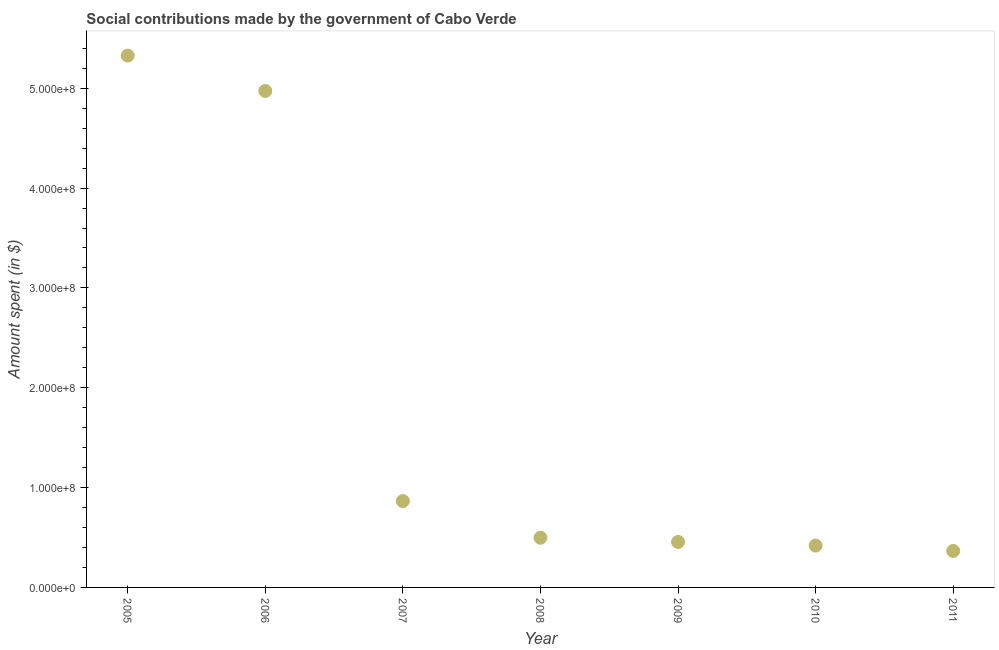What is the amount spent in making social contributions in 2006?
Provide a succinct answer. 4.97e+08. Across all years, what is the maximum amount spent in making social contributions?
Offer a terse response. 5.33e+08. Across all years, what is the minimum amount spent in making social contributions?
Your response must be concise. 3.65e+07. In which year was the amount spent in making social contributions maximum?
Keep it short and to the point. 2005. In which year was the amount spent in making social contributions minimum?
Your answer should be compact. 2011. What is the sum of the amount spent in making social contributions?
Give a very brief answer. 1.29e+09. What is the difference between the amount spent in making social contributions in 2005 and 2008?
Offer a terse response. 4.83e+08. What is the average amount spent in making social contributions per year?
Your answer should be compact. 1.84e+08. What is the median amount spent in making social contributions?
Your answer should be compact. 4.98e+07. Do a majority of the years between 2011 and 2008 (inclusive) have amount spent in making social contributions greater than 440000000 $?
Provide a succinct answer. Yes. What is the ratio of the amount spent in making social contributions in 2007 to that in 2010?
Give a very brief answer. 2.06. Is the amount spent in making social contributions in 2007 less than that in 2011?
Your response must be concise. No. Is the difference between the amount spent in making social contributions in 2010 and 2011 greater than the difference between any two years?
Ensure brevity in your answer.  No. What is the difference between the highest and the second highest amount spent in making social contributions?
Keep it short and to the point. 3.54e+07. What is the difference between the highest and the lowest amount spent in making social contributions?
Your answer should be compact. 4.96e+08. In how many years, is the amount spent in making social contributions greater than the average amount spent in making social contributions taken over all years?
Offer a very short reply. 2. How many dotlines are there?
Your response must be concise. 1. How many years are there in the graph?
Provide a succinct answer. 7. Are the values on the major ticks of Y-axis written in scientific E-notation?
Offer a very short reply. Yes. Does the graph contain any zero values?
Offer a terse response. No. Does the graph contain grids?
Your answer should be very brief. No. What is the title of the graph?
Ensure brevity in your answer.  Social contributions made by the government of Cabo Verde. What is the label or title of the Y-axis?
Provide a succinct answer. Amount spent (in $). What is the Amount spent (in $) in 2005?
Give a very brief answer. 5.33e+08. What is the Amount spent (in $) in 2006?
Provide a succinct answer. 4.97e+08. What is the Amount spent (in $) in 2007?
Keep it short and to the point. 8.65e+07. What is the Amount spent (in $) in 2008?
Your answer should be very brief. 4.98e+07. What is the Amount spent (in $) in 2009?
Keep it short and to the point. 4.56e+07. What is the Amount spent (in $) in 2010?
Provide a succinct answer. 4.19e+07. What is the Amount spent (in $) in 2011?
Ensure brevity in your answer.  3.65e+07. What is the difference between the Amount spent (in $) in 2005 and 2006?
Your answer should be very brief. 3.54e+07. What is the difference between the Amount spent (in $) in 2005 and 2007?
Keep it short and to the point. 4.46e+08. What is the difference between the Amount spent (in $) in 2005 and 2008?
Offer a very short reply. 4.83e+08. What is the difference between the Amount spent (in $) in 2005 and 2009?
Your answer should be very brief. 4.87e+08. What is the difference between the Amount spent (in $) in 2005 and 2010?
Your answer should be very brief. 4.91e+08. What is the difference between the Amount spent (in $) in 2005 and 2011?
Your answer should be very brief. 4.96e+08. What is the difference between the Amount spent (in $) in 2006 and 2007?
Keep it short and to the point. 4.11e+08. What is the difference between the Amount spent (in $) in 2006 and 2008?
Your answer should be very brief. 4.48e+08. What is the difference between the Amount spent (in $) in 2006 and 2009?
Make the answer very short. 4.52e+08. What is the difference between the Amount spent (in $) in 2006 and 2010?
Your answer should be very brief. 4.55e+08. What is the difference between the Amount spent (in $) in 2006 and 2011?
Ensure brevity in your answer.  4.61e+08. What is the difference between the Amount spent (in $) in 2007 and 2008?
Provide a succinct answer. 3.67e+07. What is the difference between the Amount spent (in $) in 2007 and 2009?
Ensure brevity in your answer.  4.10e+07. What is the difference between the Amount spent (in $) in 2007 and 2010?
Your answer should be compact. 4.46e+07. What is the difference between the Amount spent (in $) in 2007 and 2011?
Ensure brevity in your answer.  5.00e+07. What is the difference between the Amount spent (in $) in 2008 and 2009?
Give a very brief answer. 4.24e+06. What is the difference between the Amount spent (in $) in 2008 and 2010?
Offer a very short reply. 7.89e+06. What is the difference between the Amount spent (in $) in 2008 and 2011?
Your response must be concise. 1.33e+07. What is the difference between the Amount spent (in $) in 2009 and 2010?
Keep it short and to the point. 3.65e+06. What is the difference between the Amount spent (in $) in 2009 and 2011?
Your answer should be very brief. 9.01e+06. What is the difference between the Amount spent (in $) in 2010 and 2011?
Provide a short and direct response. 5.36e+06. What is the ratio of the Amount spent (in $) in 2005 to that in 2006?
Make the answer very short. 1.07. What is the ratio of the Amount spent (in $) in 2005 to that in 2007?
Your response must be concise. 6.16. What is the ratio of the Amount spent (in $) in 2005 to that in 2008?
Offer a very short reply. 10.7. What is the ratio of the Amount spent (in $) in 2005 to that in 2009?
Make the answer very short. 11.7. What is the ratio of the Amount spent (in $) in 2005 to that in 2010?
Your answer should be very brief. 12.71. What is the ratio of the Amount spent (in $) in 2005 to that in 2011?
Make the answer very short. 14.58. What is the ratio of the Amount spent (in $) in 2006 to that in 2007?
Give a very brief answer. 5.75. What is the ratio of the Amount spent (in $) in 2006 to that in 2008?
Your answer should be very brief. 9.99. What is the ratio of the Amount spent (in $) in 2006 to that in 2009?
Ensure brevity in your answer.  10.92. What is the ratio of the Amount spent (in $) in 2006 to that in 2010?
Provide a succinct answer. 11.87. What is the ratio of the Amount spent (in $) in 2006 to that in 2011?
Your answer should be compact. 13.61. What is the ratio of the Amount spent (in $) in 2007 to that in 2008?
Your answer should be very brief. 1.74. What is the ratio of the Amount spent (in $) in 2007 to that in 2009?
Offer a terse response. 1.9. What is the ratio of the Amount spent (in $) in 2007 to that in 2010?
Make the answer very short. 2.06. What is the ratio of the Amount spent (in $) in 2007 to that in 2011?
Ensure brevity in your answer.  2.37. What is the ratio of the Amount spent (in $) in 2008 to that in 2009?
Make the answer very short. 1.09. What is the ratio of the Amount spent (in $) in 2008 to that in 2010?
Make the answer very short. 1.19. What is the ratio of the Amount spent (in $) in 2008 to that in 2011?
Your answer should be very brief. 1.36. What is the ratio of the Amount spent (in $) in 2009 to that in 2010?
Your answer should be very brief. 1.09. What is the ratio of the Amount spent (in $) in 2009 to that in 2011?
Keep it short and to the point. 1.25. What is the ratio of the Amount spent (in $) in 2010 to that in 2011?
Your response must be concise. 1.15. 